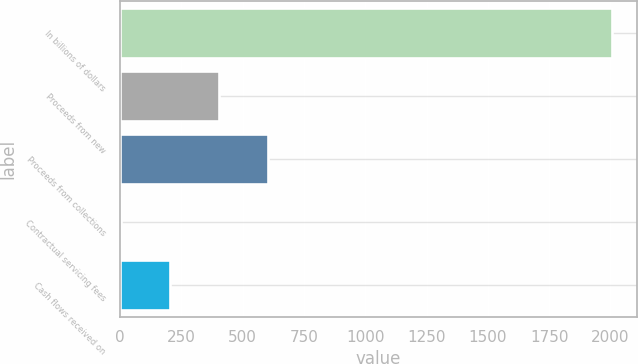Convert chart. <chart><loc_0><loc_0><loc_500><loc_500><bar_chart><fcel>In billions of dollars<fcel>Proceeds from new<fcel>Proceeds from collections<fcel>Contractual servicing fees<fcel>Cash flows received on<nl><fcel>2008<fcel>403.2<fcel>603.8<fcel>2<fcel>202.6<nl></chart> 